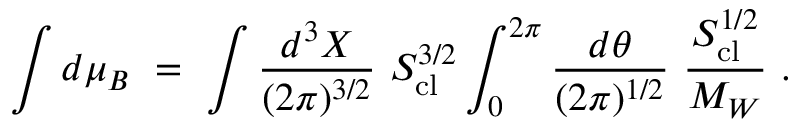<formula> <loc_0><loc_0><loc_500><loc_500>\int d \mu _ { B } \ = \ \int { \frac { d ^ { 3 } X } { ( 2 \pi ) ^ { 3 / 2 } } } \ S _ { c l } ^ { 3 / 2 } \int _ { 0 } ^ { 2 \pi } { \frac { d \theta } { ( 2 \pi ) ^ { 1 / 2 } } } \ { \frac { S _ { c l } ^ { 1 / 2 } } { M _ { W } } } \ .</formula> 